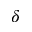<formula> <loc_0><loc_0><loc_500><loc_500>\delta</formula> 